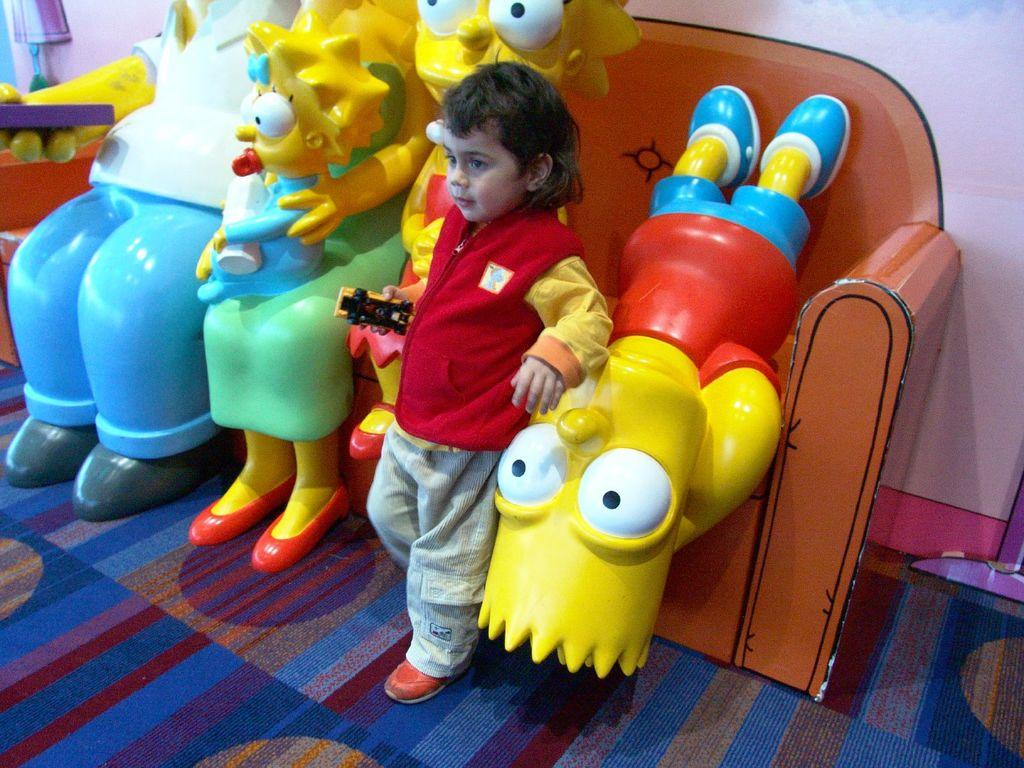What is the main subject of the image? The main subject of the image is a boy. What is the boy doing or standing near in the image? The boy is standing near toys in the image. Where are the toys located in the image? The toys are on the floor in the image. What type of lumber is the boy using to build a fort in the image? There is no lumber present in the image, and the boy is not building a fort. Can you tell me how many kettles are visible in the image? There are no kettles present in the image. 